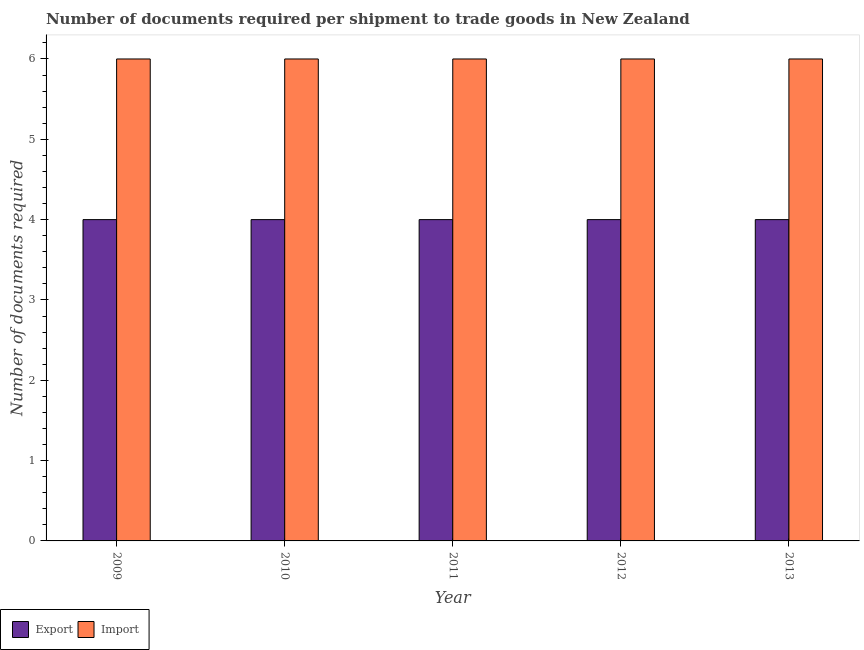How many different coloured bars are there?
Your answer should be very brief. 2. Are the number of bars per tick equal to the number of legend labels?
Offer a very short reply. Yes. Are the number of bars on each tick of the X-axis equal?
Keep it short and to the point. Yes. What is the label of the 3rd group of bars from the left?
Your answer should be very brief. 2011. What is the number of documents required to import goods in 2010?
Offer a terse response. 6. Across all years, what is the maximum number of documents required to export goods?
Provide a succinct answer. 4. Across all years, what is the minimum number of documents required to export goods?
Your response must be concise. 4. In which year was the number of documents required to export goods maximum?
Your answer should be compact. 2009. What is the total number of documents required to export goods in the graph?
Your answer should be compact. 20. What is the difference between the number of documents required to export goods in 2011 and the number of documents required to import goods in 2010?
Your answer should be very brief. 0. What is the ratio of the number of documents required to import goods in 2009 to that in 2012?
Keep it short and to the point. 1. Is the difference between the number of documents required to export goods in 2011 and 2012 greater than the difference between the number of documents required to import goods in 2011 and 2012?
Offer a terse response. No. Is the sum of the number of documents required to export goods in 2009 and 2011 greater than the maximum number of documents required to import goods across all years?
Ensure brevity in your answer.  Yes. What does the 2nd bar from the left in 2011 represents?
Your answer should be very brief. Import. What does the 1st bar from the right in 2010 represents?
Make the answer very short. Import. How many years are there in the graph?
Your answer should be very brief. 5. What is the difference between two consecutive major ticks on the Y-axis?
Provide a succinct answer. 1. Does the graph contain grids?
Your answer should be compact. No. What is the title of the graph?
Your answer should be very brief. Number of documents required per shipment to trade goods in New Zealand. Does "Electricity" appear as one of the legend labels in the graph?
Offer a terse response. No. What is the label or title of the Y-axis?
Your response must be concise. Number of documents required. What is the Number of documents required in Import in 2009?
Your answer should be very brief. 6. What is the Number of documents required of Export in 2010?
Your response must be concise. 4. What is the Number of documents required of Import in 2012?
Provide a short and direct response. 6. What is the Number of documents required in Import in 2013?
Offer a terse response. 6. Across all years, what is the maximum Number of documents required of Export?
Make the answer very short. 4. Across all years, what is the minimum Number of documents required of Export?
Your answer should be very brief. 4. What is the difference between the Number of documents required in Export in 2009 and that in 2012?
Offer a very short reply. 0. What is the difference between the Number of documents required in Import in 2009 and that in 2012?
Ensure brevity in your answer.  0. What is the difference between the Number of documents required of Export in 2010 and that in 2011?
Keep it short and to the point. 0. What is the difference between the Number of documents required in Import in 2010 and that in 2011?
Give a very brief answer. 0. What is the difference between the Number of documents required in Import in 2010 and that in 2012?
Offer a terse response. 0. What is the difference between the Number of documents required of Import in 2010 and that in 2013?
Offer a very short reply. 0. What is the difference between the Number of documents required in Export in 2011 and that in 2012?
Make the answer very short. 0. What is the difference between the Number of documents required in Import in 2011 and that in 2012?
Ensure brevity in your answer.  0. What is the difference between the Number of documents required in Import in 2011 and that in 2013?
Ensure brevity in your answer.  0. What is the difference between the Number of documents required in Export in 2012 and that in 2013?
Keep it short and to the point. 0. What is the difference between the Number of documents required in Import in 2012 and that in 2013?
Your response must be concise. 0. What is the difference between the Number of documents required of Export in 2009 and the Number of documents required of Import in 2011?
Keep it short and to the point. -2. What is the difference between the Number of documents required of Export in 2010 and the Number of documents required of Import in 2013?
Make the answer very short. -2. What is the average Number of documents required of Export per year?
Give a very brief answer. 4. In the year 2009, what is the difference between the Number of documents required in Export and Number of documents required in Import?
Offer a very short reply. -2. In the year 2010, what is the difference between the Number of documents required of Export and Number of documents required of Import?
Give a very brief answer. -2. In the year 2012, what is the difference between the Number of documents required of Export and Number of documents required of Import?
Give a very brief answer. -2. What is the ratio of the Number of documents required of Export in 2009 to that in 2010?
Provide a succinct answer. 1. What is the ratio of the Number of documents required of Export in 2009 to that in 2011?
Provide a short and direct response. 1. What is the ratio of the Number of documents required in Import in 2009 to that in 2011?
Keep it short and to the point. 1. What is the ratio of the Number of documents required of Export in 2009 to that in 2012?
Ensure brevity in your answer.  1. What is the ratio of the Number of documents required of Import in 2009 to that in 2012?
Provide a succinct answer. 1. What is the ratio of the Number of documents required of Export in 2009 to that in 2013?
Give a very brief answer. 1. What is the ratio of the Number of documents required in Import in 2009 to that in 2013?
Provide a short and direct response. 1. What is the ratio of the Number of documents required of Export in 2010 to that in 2011?
Provide a succinct answer. 1. What is the ratio of the Number of documents required of Import in 2010 to that in 2011?
Your response must be concise. 1. What is the ratio of the Number of documents required of Export in 2010 to that in 2012?
Offer a very short reply. 1. What is the ratio of the Number of documents required of Import in 2010 to that in 2012?
Keep it short and to the point. 1. What is the ratio of the Number of documents required of Export in 2010 to that in 2013?
Give a very brief answer. 1. What is the ratio of the Number of documents required of Export in 2011 to that in 2012?
Your answer should be compact. 1. What is the ratio of the Number of documents required in Export in 2011 to that in 2013?
Your response must be concise. 1. What is the ratio of the Number of documents required of Import in 2011 to that in 2013?
Your answer should be compact. 1. What is the ratio of the Number of documents required in Export in 2012 to that in 2013?
Offer a terse response. 1. What is the difference between the highest and the second highest Number of documents required in Export?
Provide a short and direct response. 0. What is the difference between the highest and the lowest Number of documents required in Export?
Your response must be concise. 0. What is the difference between the highest and the lowest Number of documents required of Import?
Your answer should be very brief. 0. 